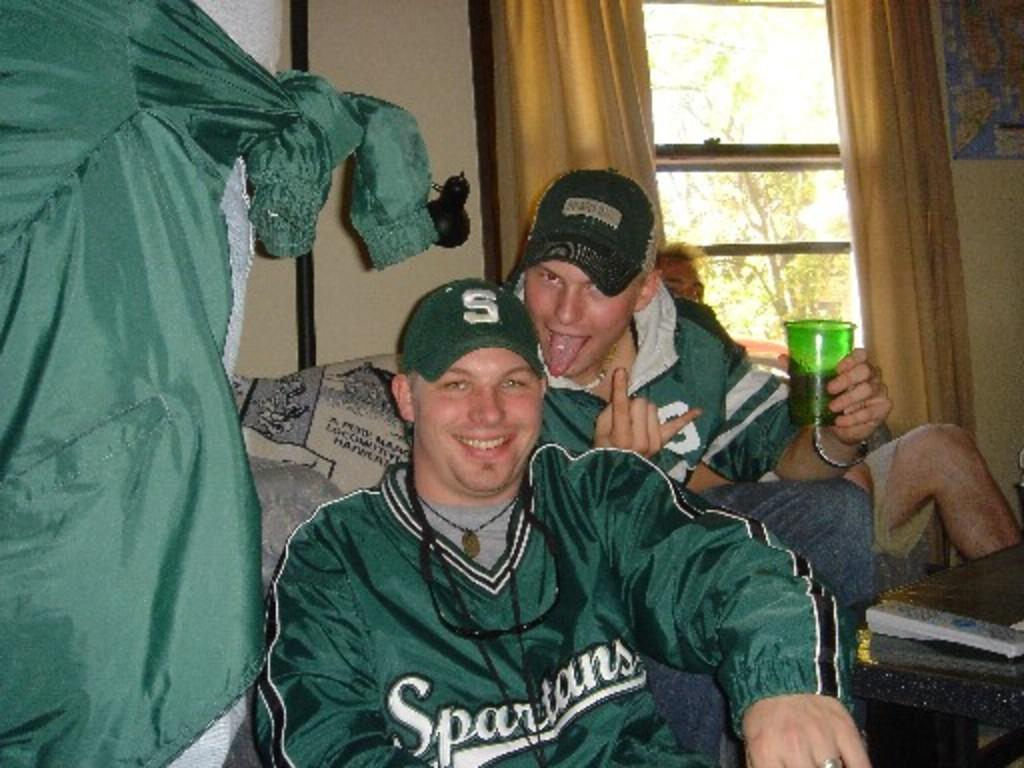<image>
Write a terse but informative summary of the picture. a man in a Spartans jersey smiles next to a funny faced man 